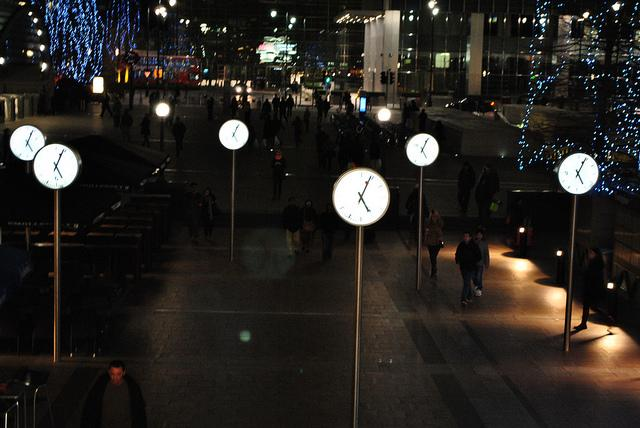Why are there blue lights on the trees? christmas 